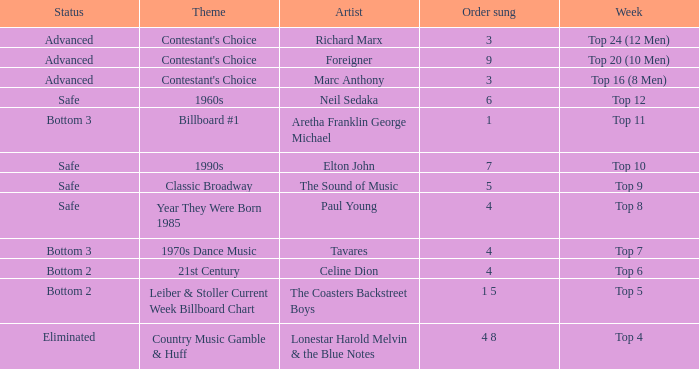What is the status when the artist is Neil Sedaka? Safe. 